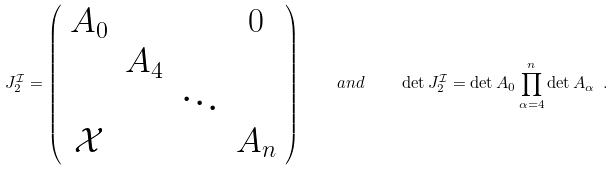<formula> <loc_0><loc_0><loc_500><loc_500>J _ { 2 } ^ { \mathcal { I } } = \left ( \begin{array} { c c c c } A _ { 0 } & & & 0 \\ & A _ { 4 } & & \\ & & \ddots & \\ \mathcal { X } & & & A _ { n } \end{array} \right ) \quad a n d \quad \det J _ { 2 } ^ { \mathcal { I } } = \det A _ { 0 } \prod _ { \alpha = 4 } ^ { n } \det A _ { \alpha } \ .</formula> 